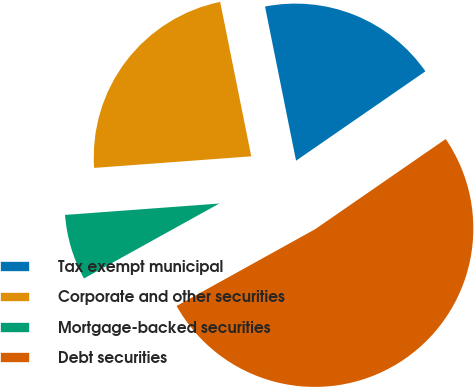Convert chart to OTSL. <chart><loc_0><loc_0><loc_500><loc_500><pie_chart><fcel>Tax exempt municipal<fcel>Corporate and other securities<fcel>Mortgage-backed securities<fcel>Debt securities<nl><fcel>18.54%<fcel>23.01%<fcel>6.88%<fcel>51.57%<nl></chart> 